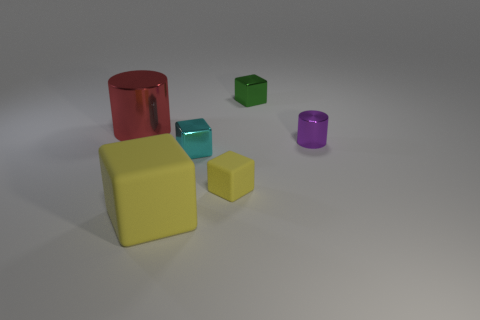Do the metallic cylinder in front of the red metallic cylinder and the red object have the same size?
Keep it short and to the point. No. The big yellow rubber object has what shape?
Offer a very short reply. Cube. There is a rubber thing that is the same color as the big rubber block; what is its size?
Ensure brevity in your answer.  Small. Does the large thing in front of the big red metallic thing have the same material as the small yellow object?
Provide a short and direct response. Yes. Is there a thing that has the same color as the large block?
Give a very brief answer. Yes. Do the object to the right of the green shiny object and the yellow matte object behind the big yellow matte block have the same shape?
Keep it short and to the point. No. Is there a big red thing that has the same material as the purple object?
Provide a short and direct response. Yes. How many yellow objects are shiny blocks or shiny cylinders?
Give a very brief answer. 0. There is a object that is left of the cyan thing and behind the tiny purple thing; what is its size?
Give a very brief answer. Large. Are there more cylinders in front of the red metallic cylinder than tiny yellow metal balls?
Your answer should be compact. Yes. 